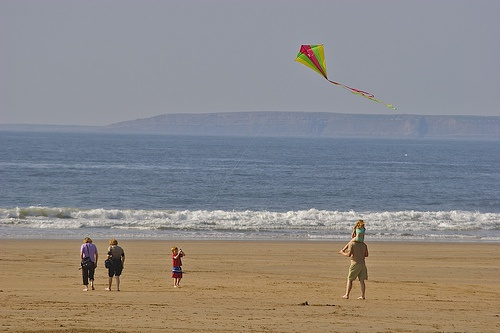Describe the objects in this image and their specific colors. I can see kite in darkgray, olive, green, and brown tones, people in darkgray, maroon, tan, and gray tones, people in darkgray, black, purple, and tan tones, people in darkgray, black, maroon, and gray tones, and people in darkgray, maroon, black, gray, and tan tones in this image. 